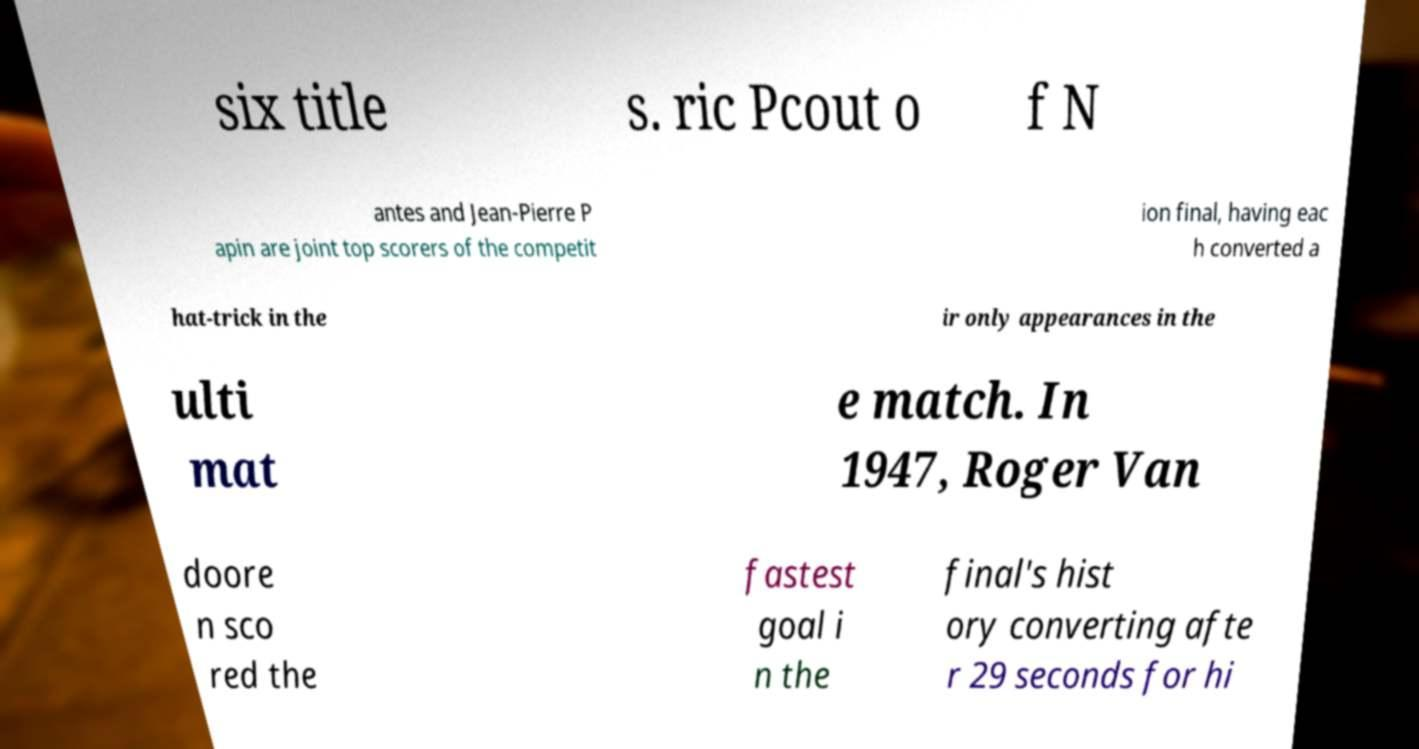Please read and relay the text visible in this image. What does it say? six title s. ric Pcout o f N antes and Jean-Pierre P apin are joint top scorers of the competit ion final, having eac h converted a hat-trick in the ir only appearances in the ulti mat e match. In 1947, Roger Van doore n sco red the fastest goal i n the final's hist ory converting afte r 29 seconds for hi 